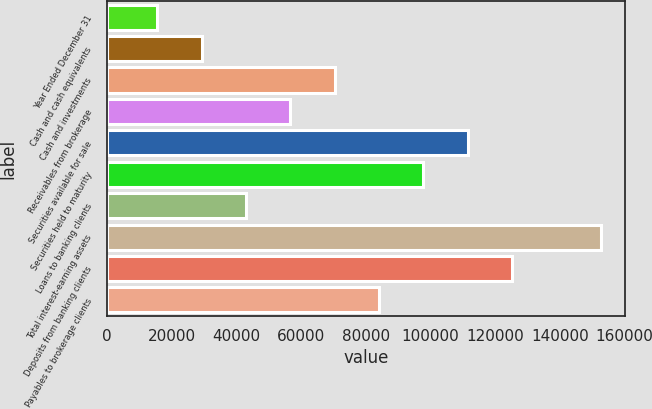<chart> <loc_0><loc_0><loc_500><loc_500><bar_chart><fcel>Year Ended December 31<fcel>Cash and cash equivalents<fcel>Cash and investments<fcel>Receivables from brokerage<fcel>Securities available for sale<fcel>Securities held to maturity<fcel>Loans to banking clients<fcel>Total interest-earning assets<fcel>Deposits from banking clients<fcel>Payables to brokerage clients<nl><fcel>15598.3<fcel>29295.6<fcel>70387.5<fcel>56690.2<fcel>111479<fcel>97782.1<fcel>42992.9<fcel>152571<fcel>125177<fcel>84084.8<nl></chart> 